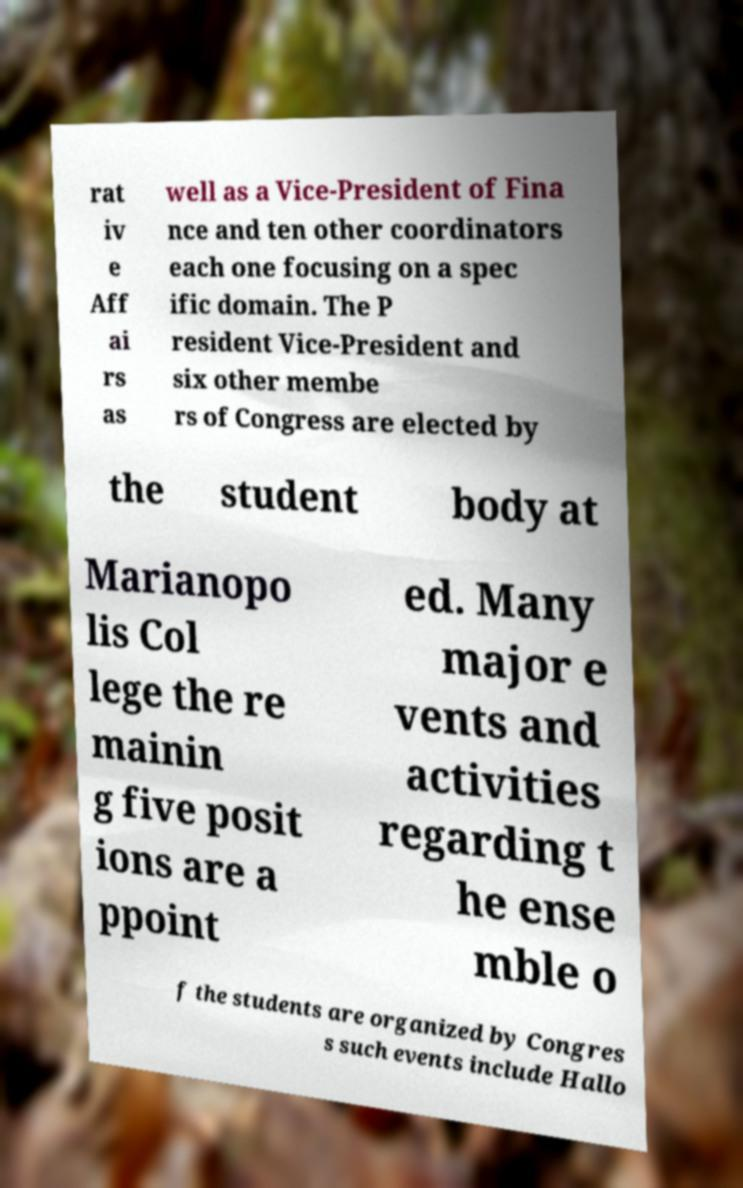Can you read and provide the text displayed in the image?This photo seems to have some interesting text. Can you extract and type it out for me? rat iv e Aff ai rs as well as a Vice-President of Fina nce and ten other coordinators each one focusing on a spec ific domain. The P resident Vice-President and six other membe rs of Congress are elected by the student body at Marianopo lis Col lege the re mainin g five posit ions are a ppoint ed. Many major e vents and activities regarding t he ense mble o f the students are organized by Congres s such events include Hallo 